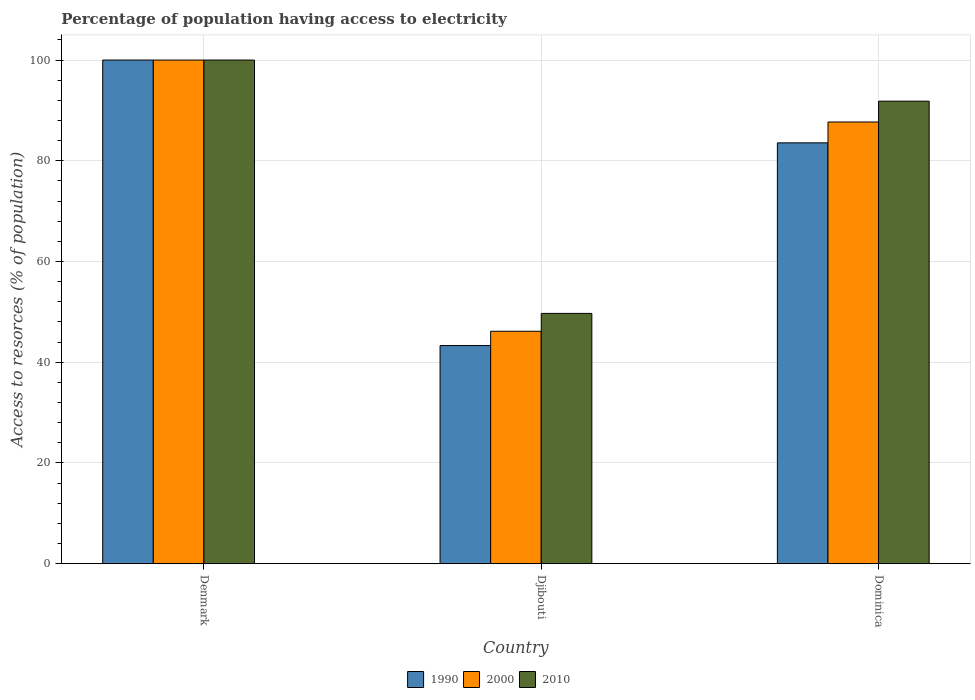Are the number of bars on each tick of the X-axis equal?
Make the answer very short. Yes. How many bars are there on the 1st tick from the left?
Make the answer very short. 3. How many bars are there on the 3rd tick from the right?
Provide a short and direct response. 3. What is the label of the 3rd group of bars from the left?
Make the answer very short. Dominica. In how many cases, is the number of bars for a given country not equal to the number of legend labels?
Provide a succinct answer. 0. What is the percentage of population having access to electricity in 1990 in Denmark?
Keep it short and to the point. 100. Across all countries, what is the maximum percentage of population having access to electricity in 1990?
Your answer should be compact. 100. Across all countries, what is the minimum percentage of population having access to electricity in 1990?
Keep it short and to the point. 43.32. In which country was the percentage of population having access to electricity in 2010 minimum?
Offer a very short reply. Djibouti. What is the total percentage of population having access to electricity in 1990 in the graph?
Keep it short and to the point. 226.88. What is the difference between the percentage of population having access to electricity in 2000 in Denmark and that in Dominica?
Give a very brief answer. 12.3. What is the difference between the percentage of population having access to electricity in 2010 in Djibouti and the percentage of population having access to electricity in 1990 in Dominica?
Your response must be concise. -33.86. What is the average percentage of population having access to electricity in 1990 per country?
Make the answer very short. 75.63. What is the difference between the percentage of population having access to electricity of/in 1990 and percentage of population having access to electricity of/in 2000 in Djibouti?
Your response must be concise. -2.84. What is the ratio of the percentage of population having access to electricity in 2010 in Denmark to that in Dominica?
Provide a short and direct response. 1.09. Is the difference between the percentage of population having access to electricity in 1990 in Djibouti and Dominica greater than the difference between the percentage of population having access to electricity in 2000 in Djibouti and Dominica?
Your answer should be very brief. Yes. What is the difference between the highest and the second highest percentage of population having access to electricity in 2000?
Provide a succinct answer. 53.84. What is the difference between the highest and the lowest percentage of population having access to electricity in 1990?
Provide a short and direct response. 56.68. What does the 2nd bar from the right in Denmark represents?
Offer a terse response. 2000. Are all the bars in the graph horizontal?
Provide a succinct answer. No. What is the difference between two consecutive major ticks on the Y-axis?
Keep it short and to the point. 20. Are the values on the major ticks of Y-axis written in scientific E-notation?
Keep it short and to the point. No. Where does the legend appear in the graph?
Make the answer very short. Bottom center. How are the legend labels stacked?
Keep it short and to the point. Horizontal. What is the title of the graph?
Give a very brief answer. Percentage of population having access to electricity. What is the label or title of the Y-axis?
Provide a short and direct response. Access to resorces (% of population). What is the Access to resorces (% of population) of 1990 in Denmark?
Give a very brief answer. 100. What is the Access to resorces (% of population) in 2000 in Denmark?
Your response must be concise. 100. What is the Access to resorces (% of population) in 2010 in Denmark?
Offer a very short reply. 100. What is the Access to resorces (% of population) in 1990 in Djibouti?
Your response must be concise. 43.32. What is the Access to resorces (% of population) in 2000 in Djibouti?
Offer a very short reply. 46.16. What is the Access to resorces (% of population) of 2010 in Djibouti?
Make the answer very short. 49.7. What is the Access to resorces (% of population) of 1990 in Dominica?
Offer a very short reply. 83.56. What is the Access to resorces (% of population) of 2000 in Dominica?
Ensure brevity in your answer.  87.7. What is the Access to resorces (% of population) in 2010 in Dominica?
Provide a short and direct response. 91.84. Across all countries, what is the maximum Access to resorces (% of population) of 1990?
Your answer should be very brief. 100. Across all countries, what is the maximum Access to resorces (% of population) in 2000?
Your answer should be very brief. 100. Across all countries, what is the minimum Access to resorces (% of population) in 1990?
Make the answer very short. 43.32. Across all countries, what is the minimum Access to resorces (% of population) in 2000?
Your answer should be compact. 46.16. Across all countries, what is the minimum Access to resorces (% of population) in 2010?
Your answer should be compact. 49.7. What is the total Access to resorces (% of population) of 1990 in the graph?
Your answer should be very brief. 226.88. What is the total Access to resorces (% of population) in 2000 in the graph?
Give a very brief answer. 233.86. What is the total Access to resorces (% of population) in 2010 in the graph?
Offer a terse response. 241.54. What is the difference between the Access to resorces (% of population) in 1990 in Denmark and that in Djibouti?
Your answer should be compact. 56.68. What is the difference between the Access to resorces (% of population) of 2000 in Denmark and that in Djibouti?
Provide a short and direct response. 53.84. What is the difference between the Access to resorces (% of population) in 2010 in Denmark and that in Djibouti?
Give a very brief answer. 50.3. What is the difference between the Access to resorces (% of population) of 1990 in Denmark and that in Dominica?
Ensure brevity in your answer.  16.44. What is the difference between the Access to resorces (% of population) of 2010 in Denmark and that in Dominica?
Give a very brief answer. 8.16. What is the difference between the Access to resorces (% of population) in 1990 in Djibouti and that in Dominica?
Make the answer very short. -40.25. What is the difference between the Access to resorces (% of population) in 2000 in Djibouti and that in Dominica?
Ensure brevity in your answer.  -41.54. What is the difference between the Access to resorces (% of population) in 2010 in Djibouti and that in Dominica?
Your answer should be very brief. -42.14. What is the difference between the Access to resorces (% of population) of 1990 in Denmark and the Access to resorces (% of population) of 2000 in Djibouti?
Your answer should be compact. 53.84. What is the difference between the Access to resorces (% of population) of 1990 in Denmark and the Access to resorces (% of population) of 2010 in Djibouti?
Give a very brief answer. 50.3. What is the difference between the Access to resorces (% of population) of 2000 in Denmark and the Access to resorces (% of population) of 2010 in Djibouti?
Your response must be concise. 50.3. What is the difference between the Access to resorces (% of population) in 1990 in Denmark and the Access to resorces (% of population) in 2000 in Dominica?
Keep it short and to the point. 12.3. What is the difference between the Access to resorces (% of population) in 1990 in Denmark and the Access to resorces (% of population) in 2010 in Dominica?
Provide a succinct answer. 8.16. What is the difference between the Access to resorces (% of population) in 2000 in Denmark and the Access to resorces (% of population) in 2010 in Dominica?
Offer a very short reply. 8.16. What is the difference between the Access to resorces (% of population) of 1990 in Djibouti and the Access to resorces (% of population) of 2000 in Dominica?
Provide a succinct answer. -44.38. What is the difference between the Access to resorces (% of population) of 1990 in Djibouti and the Access to resorces (% of population) of 2010 in Dominica?
Ensure brevity in your answer.  -48.52. What is the difference between the Access to resorces (% of population) in 2000 in Djibouti and the Access to resorces (% of population) in 2010 in Dominica?
Offer a terse response. -45.68. What is the average Access to resorces (% of population) in 1990 per country?
Offer a very short reply. 75.63. What is the average Access to resorces (% of population) in 2000 per country?
Offer a terse response. 77.95. What is the average Access to resorces (% of population) of 2010 per country?
Ensure brevity in your answer.  80.51. What is the difference between the Access to resorces (% of population) in 1990 and Access to resorces (% of population) in 2000 in Denmark?
Provide a succinct answer. 0. What is the difference between the Access to resorces (% of population) of 1990 and Access to resorces (% of population) of 2010 in Denmark?
Keep it short and to the point. 0. What is the difference between the Access to resorces (% of population) of 1990 and Access to resorces (% of population) of 2000 in Djibouti?
Your response must be concise. -2.84. What is the difference between the Access to resorces (% of population) of 1990 and Access to resorces (% of population) of 2010 in Djibouti?
Make the answer very short. -6.38. What is the difference between the Access to resorces (% of population) in 2000 and Access to resorces (% of population) in 2010 in Djibouti?
Make the answer very short. -3.54. What is the difference between the Access to resorces (% of population) of 1990 and Access to resorces (% of population) of 2000 in Dominica?
Ensure brevity in your answer.  -4.14. What is the difference between the Access to resorces (% of population) in 1990 and Access to resorces (% of population) in 2010 in Dominica?
Your response must be concise. -8.28. What is the difference between the Access to resorces (% of population) in 2000 and Access to resorces (% of population) in 2010 in Dominica?
Keep it short and to the point. -4.14. What is the ratio of the Access to resorces (% of population) of 1990 in Denmark to that in Djibouti?
Give a very brief answer. 2.31. What is the ratio of the Access to resorces (% of population) in 2000 in Denmark to that in Djibouti?
Offer a very short reply. 2.17. What is the ratio of the Access to resorces (% of population) in 2010 in Denmark to that in Djibouti?
Provide a short and direct response. 2.01. What is the ratio of the Access to resorces (% of population) of 1990 in Denmark to that in Dominica?
Your answer should be compact. 1.2. What is the ratio of the Access to resorces (% of population) of 2000 in Denmark to that in Dominica?
Make the answer very short. 1.14. What is the ratio of the Access to resorces (% of population) of 2010 in Denmark to that in Dominica?
Keep it short and to the point. 1.09. What is the ratio of the Access to resorces (% of population) of 1990 in Djibouti to that in Dominica?
Your answer should be compact. 0.52. What is the ratio of the Access to resorces (% of population) of 2000 in Djibouti to that in Dominica?
Your answer should be very brief. 0.53. What is the ratio of the Access to resorces (% of population) in 2010 in Djibouti to that in Dominica?
Ensure brevity in your answer.  0.54. What is the difference between the highest and the second highest Access to resorces (% of population) of 1990?
Offer a terse response. 16.44. What is the difference between the highest and the second highest Access to resorces (% of population) of 2000?
Your answer should be very brief. 12.3. What is the difference between the highest and the second highest Access to resorces (% of population) in 2010?
Provide a succinct answer. 8.16. What is the difference between the highest and the lowest Access to resorces (% of population) of 1990?
Provide a succinct answer. 56.68. What is the difference between the highest and the lowest Access to resorces (% of population) of 2000?
Your answer should be compact. 53.84. What is the difference between the highest and the lowest Access to resorces (% of population) of 2010?
Provide a succinct answer. 50.3. 